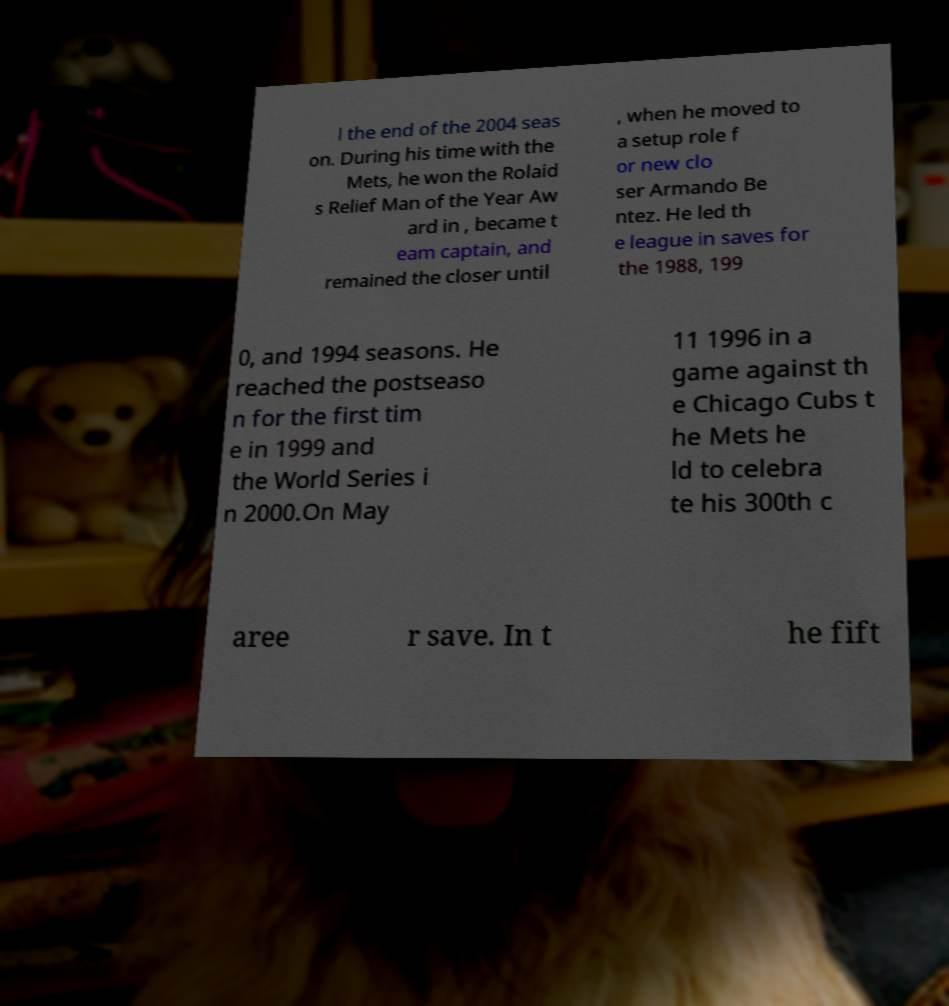What messages or text are displayed in this image? I need them in a readable, typed format. l the end of the 2004 seas on. During his time with the Mets, he won the Rolaid s Relief Man of the Year Aw ard in , became t eam captain, and remained the closer until , when he moved to a setup role f or new clo ser Armando Be ntez. He led th e league in saves for the 1988, 199 0, and 1994 seasons. He reached the postseaso n for the first tim e in 1999 and the World Series i n 2000.On May 11 1996 in a game against th e Chicago Cubs t he Mets he ld to celebra te his 300th c aree r save. In t he fift 